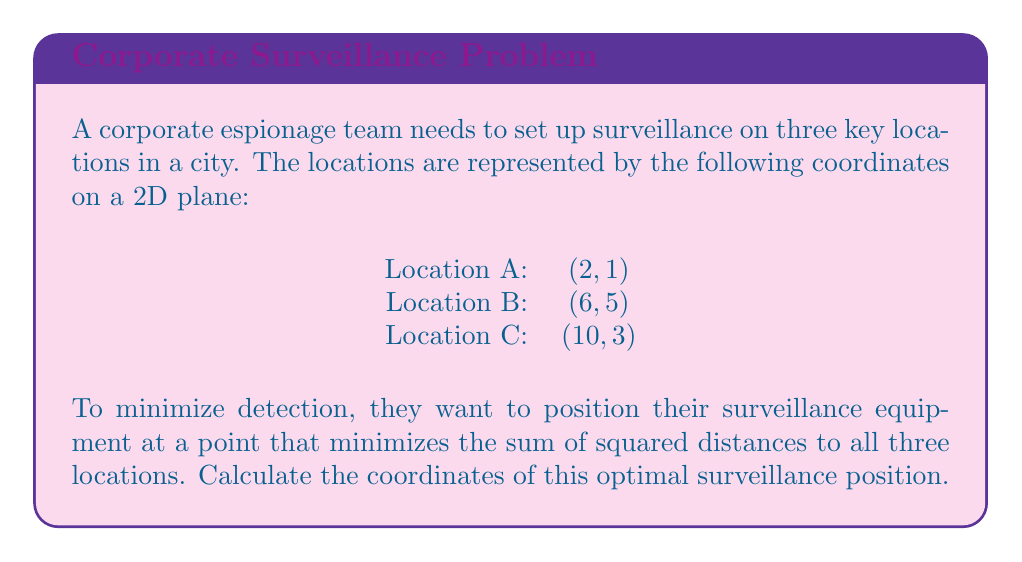Can you answer this question? To find the optimal surveillance position, we need to use the concept of the centroid in coordinate geometry. The centroid minimizes the sum of squared distances to a set of points.

Step 1: Calculate the x-coordinate of the centroid.
The x-coordinate of the centroid is the average of all x-coordinates:

$$ x = \frac{x_A + x_B + x_C}{3} = \frac{2 + 6 + 10}{3} = 6 $$

Step 2: Calculate the y-coordinate of the centroid.
The y-coordinate of the centroid is the average of all y-coordinates:

$$ y = \frac{y_A + y_B + y_C}{3} = \frac{1 + 5 + 3}{3} = 3 $$

Step 3: Verify that this point minimizes the sum of squared distances.
The sum of squared distances from a point $(x, y)$ to the three locations is given by:

$$ D = (x-2)^2 + (y-1)^2 + (x-6)^2 + (y-5)^2 + (x-10)^2 + (y-3)^2 $$

To minimize this, we take partial derivatives with respect to x and y and set them to zero:

$$ \frac{\partial D}{\partial x} = 2(x-2) + 2(x-6) + 2(x-10) = 6x - 36 = 0 $$
$$ \frac{\partial D}{\partial y} = 2(y-1) + 2(y-5) + 2(y-3) = 6y - 18 = 0 $$

Solving these equations confirms that $x = 6$ and $y = 3$ is indeed the minimum.

Therefore, the optimal surveillance position is at the point (6, 3).
Answer: The optimal surveillance position is at coordinates (6, 3). 